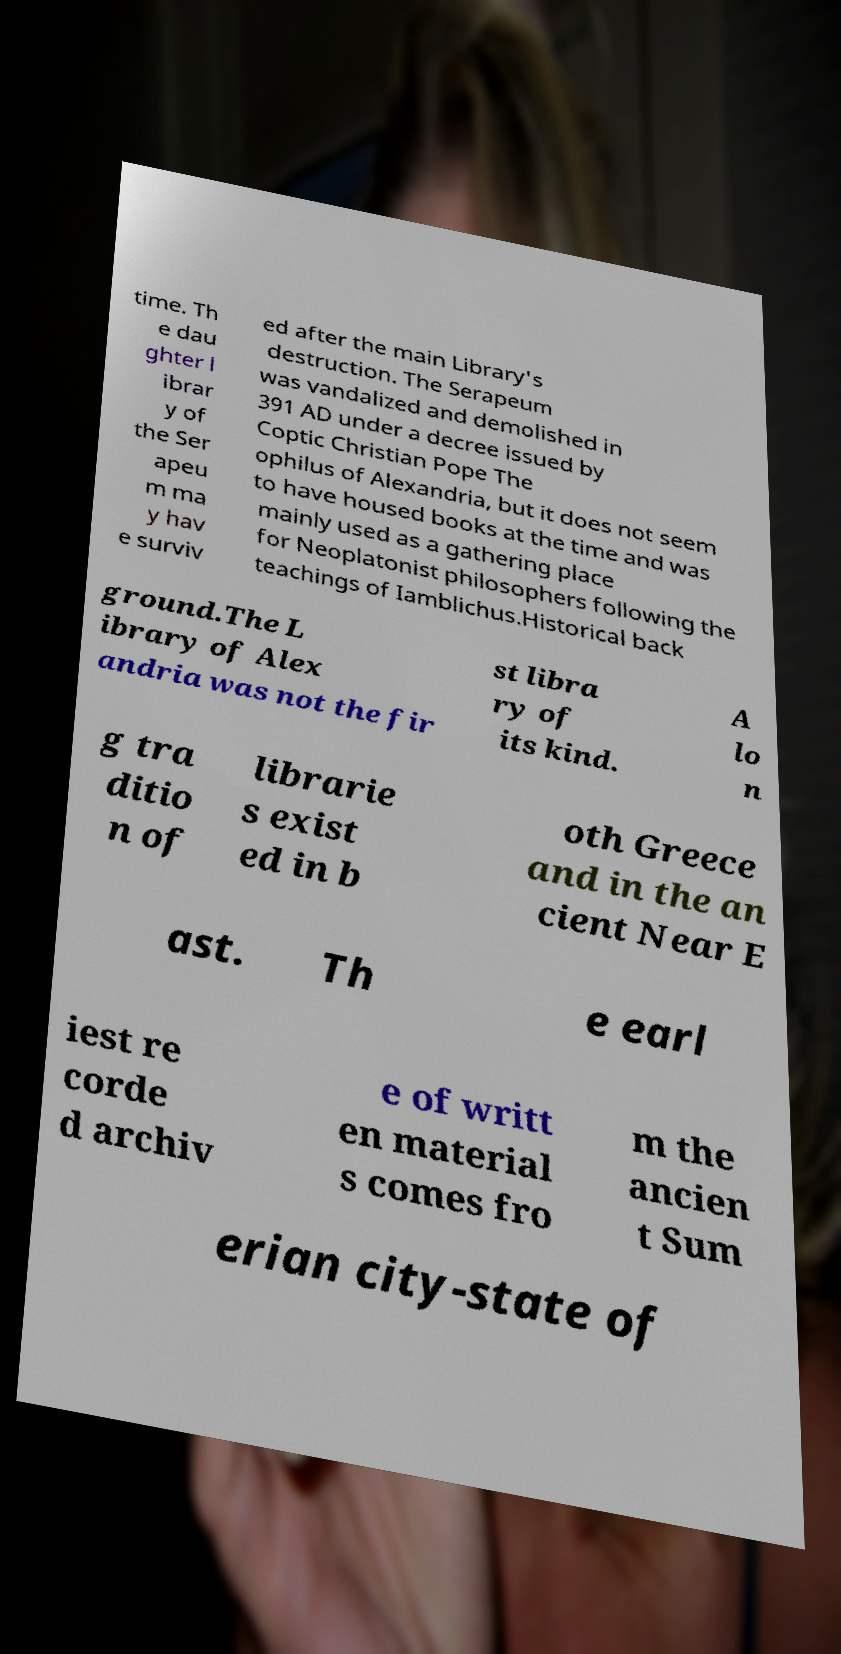What messages or text are displayed in this image? I need them in a readable, typed format. time. Th e dau ghter l ibrar y of the Ser apeu m ma y hav e surviv ed after the main Library's destruction. The Serapeum was vandalized and demolished in 391 AD under a decree issued by Coptic Christian Pope The ophilus of Alexandria, but it does not seem to have housed books at the time and was mainly used as a gathering place for Neoplatonist philosophers following the teachings of Iamblichus.Historical back ground.The L ibrary of Alex andria was not the fir st libra ry of its kind. A lo n g tra ditio n of librarie s exist ed in b oth Greece and in the an cient Near E ast. Th e earl iest re corde d archiv e of writt en material s comes fro m the ancien t Sum erian city-state of 